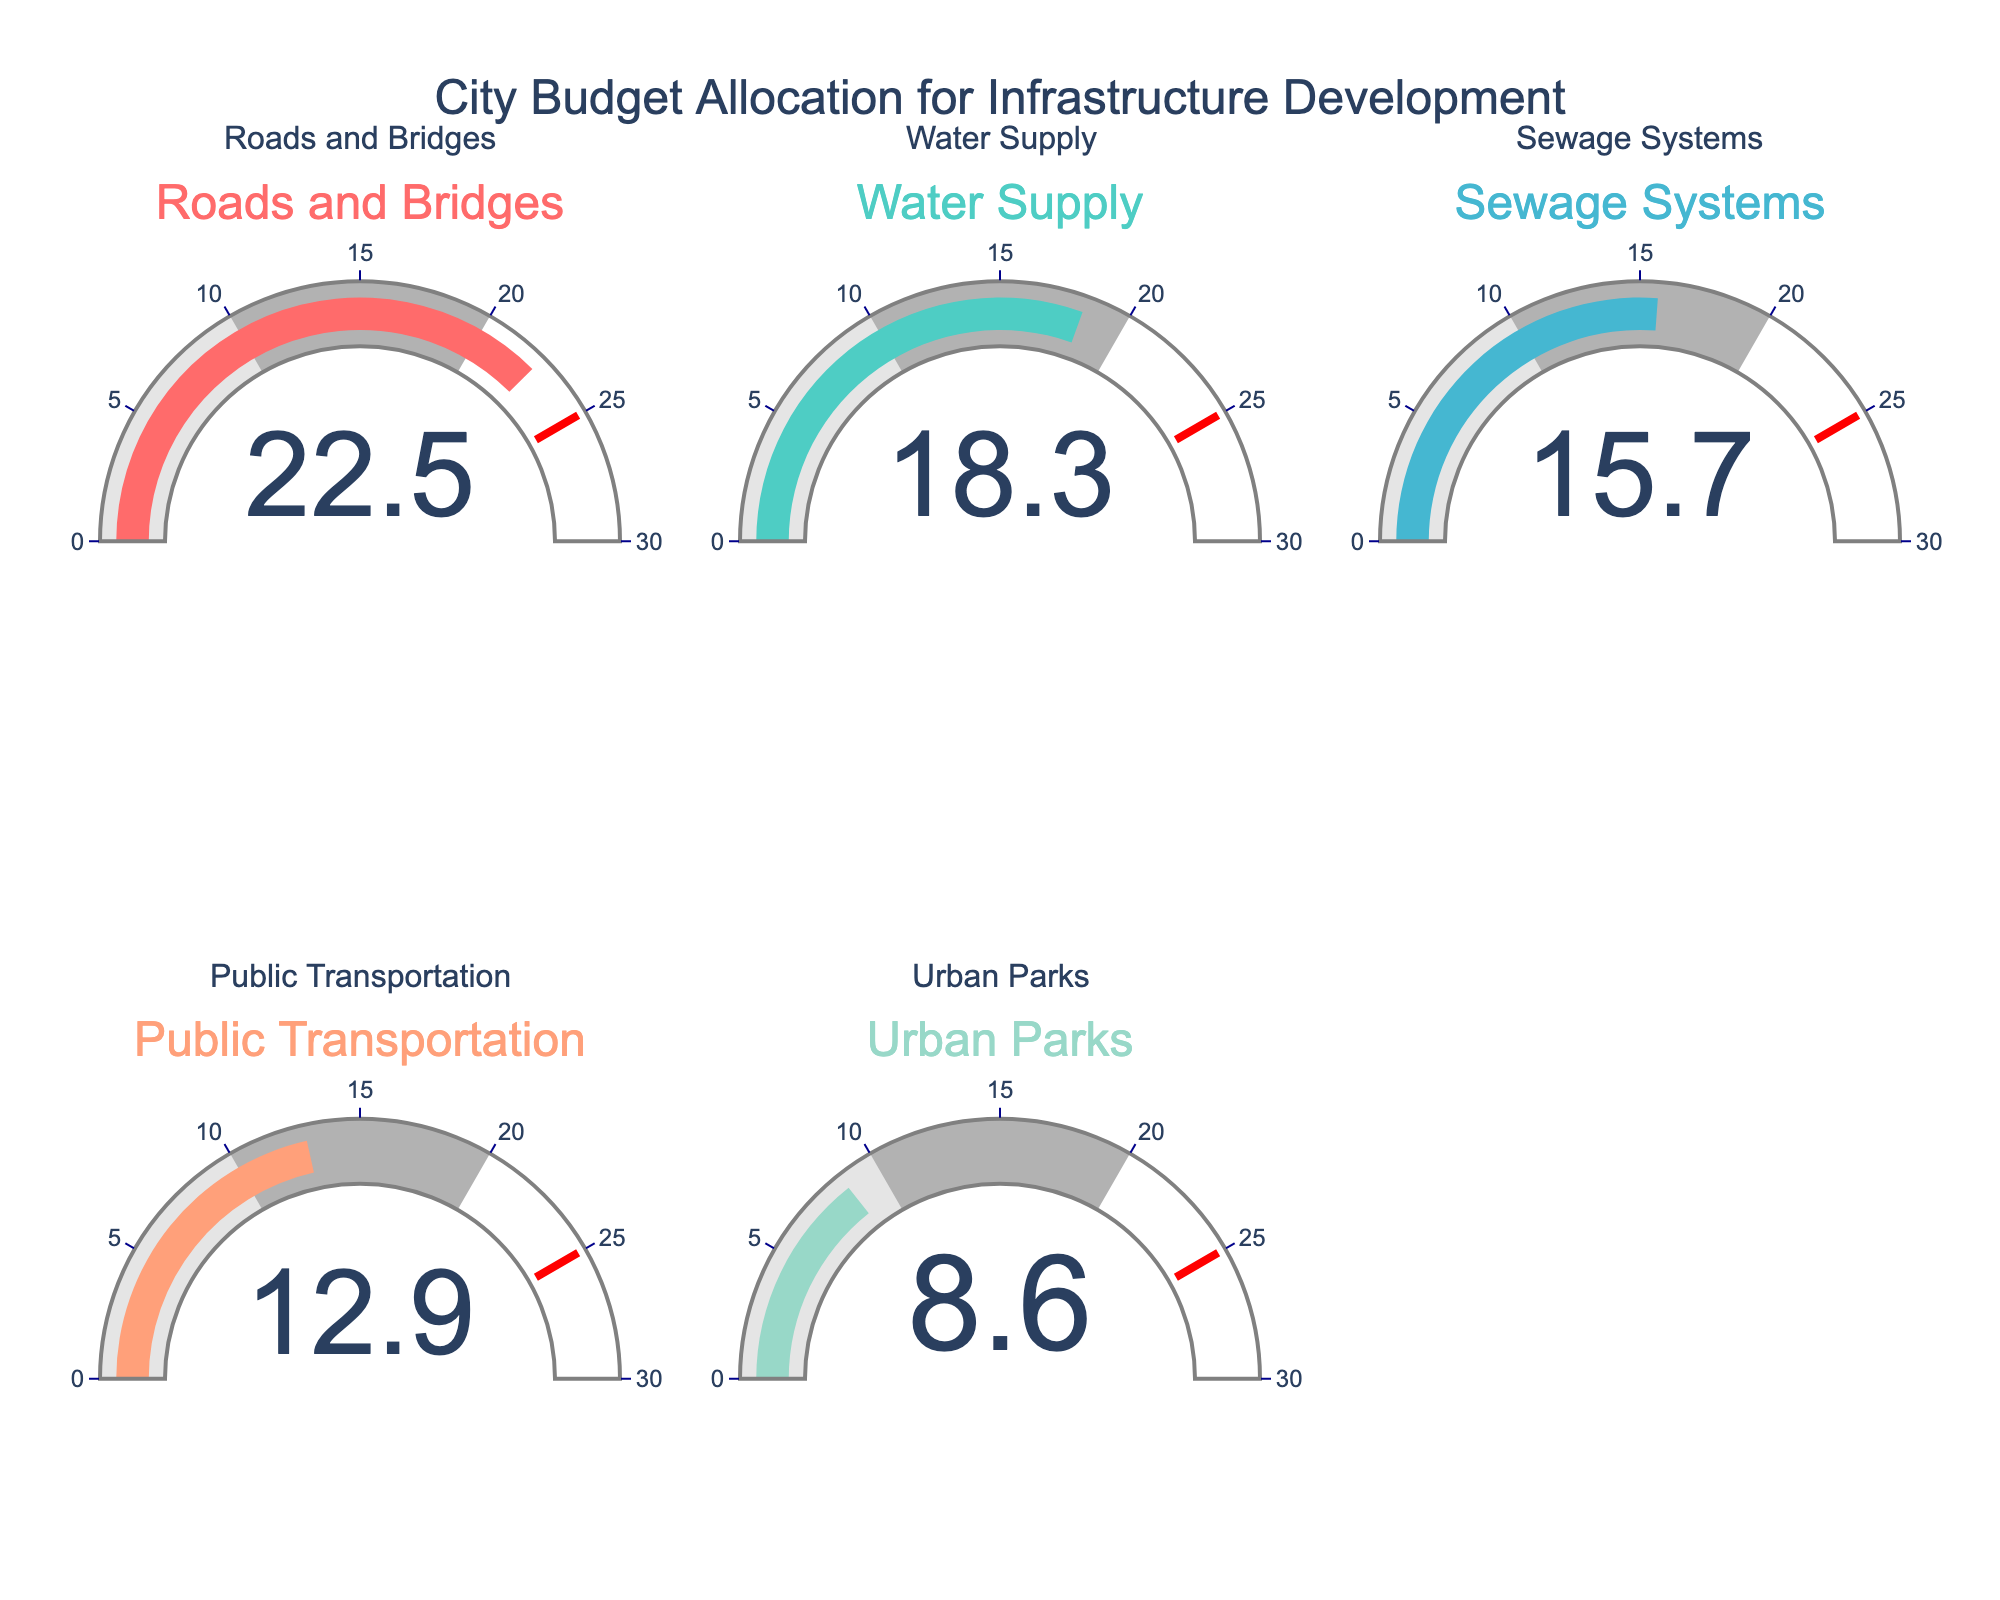What is the percentage of the city budget allocated to Roads and Bridges? The percentage for Roads and Bridges is displayed directly on its gauge.
Answer: 22.5% How does the percentage allocated to Water Supply compare to that for Sewage Systems? The gauge for Water Supply shows 18.3% and the gauge for Sewage Systems shows 15.7%. 18.3% is greater than 15.7%.
Answer: Water Supply is greater What two categories combined make up more than 40% of the city budget? Adding the percentages of the first two highest categories: Roads and Bridges (22.5%) and Water Supply (18.3%) gives a total of 40.8%, which is more than 40%.
Answer: Roads and Bridges, Water Supply Which category has the lowest percentage in the budget allocation? The gauge for Urban Parks shows the smallest percentage, 8.6%.
Answer: Urban Parks What is the average percentage allocation for all five categories? Sum the percentages: 22.5 + 18.3 + 15.7 + 12.9 + 8.6 = 78. Then divide by the number of categories: 78 / 5 = 15.6.
Answer: 15.6% Which category's allocation is closest to 20%? Comparing the values closest to 20%, Roads and Bridges has 22.5% while Water Supply has 18.3%. Water Supply is closest.
Answer: Water Supply What is the total percentage allocated to Public Transportation and Urban Parks combined? Adding the percentages of Public Transportation (12.9%) and Urban Parks (8.6%) gives 12.9 + 8.6 = 21.5%.
Answer: 21.5% Is the percentage spent on Roads and Bridges more than twice that spent on Urban Parks? Roads and Bridges have 22.5% while Urban Parks have 8.6%. Twice 8.6% is 17.2%, and 22.5% exceeds 17.2%.
Answer: Yes If the budget for Sewage Systems was increased by 4%, what would be the new percentage? The original percentage for Sewage Systems is 15.7%. Adding 4% to 15.7% gives 15.7 + 4 = 19.7%.
Answer: 19.7% What is the difference in percentage points between the highest and lowest allocation categories? The highest is Roads and Bridges at 22.5% and the lowest is Urban Parks at 8.6%. The difference is 22.5 - 8.6 = 13.9 percentage points.
Answer: 13.9 